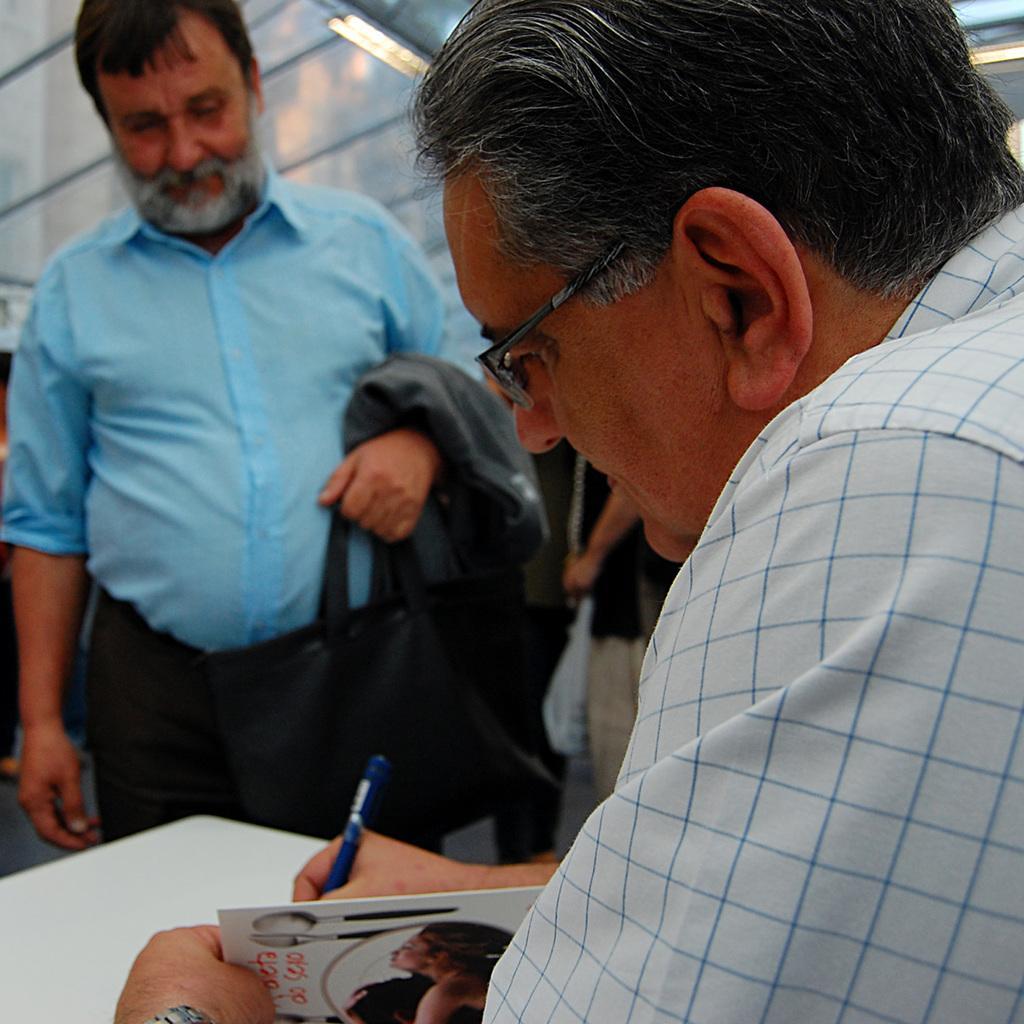Please provide a concise description of this image. In this image we can see this person wearing shirt and spectacles is sitting and holding a book and writing with the pen. Here we can see the white table and this person wearing blue shirt and holding a jacket is standing on the floor. In the background, we can see a few more people and lights on the ceiling. 